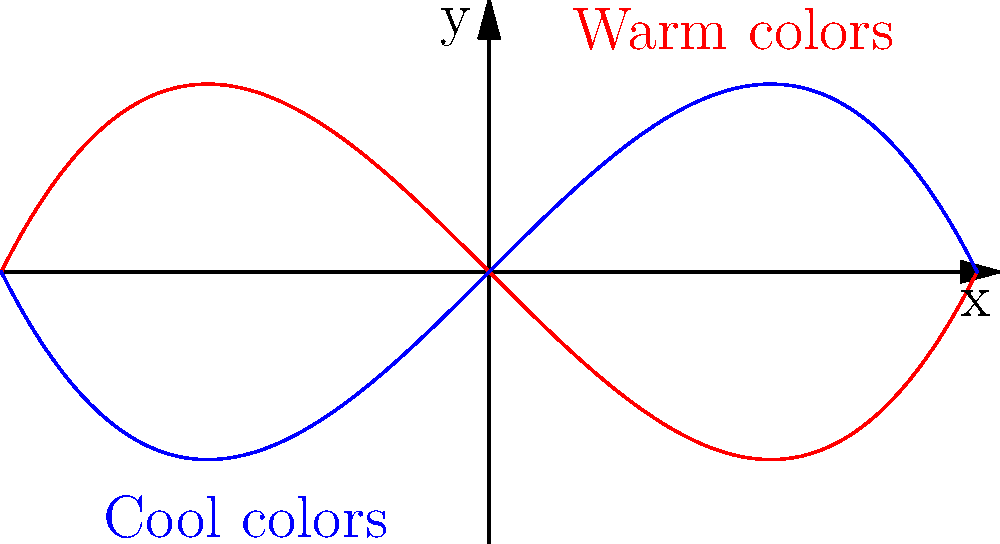In character development, how can the use of warm colors (represented by the red curve) and cool colors (represented by the blue curve) in a character's environment or appearance influence the reader's perception of their emotional state? 1. Color theory in storytelling:
   - Colors evoke emotional responses in readers
   - Warm colors (reds, oranges, yellows) are associated with energy, passion, and intensity
   - Cool colors (blues, greens, purples) are associated with calmness, sadness, or introspection

2. Warm colors (red curve):
   - Rising curve represents increasing emotional intensity
   - Can be used to depict characters feeling anger, excitement, or love
   - Example: A character in a red-lit room might appear more aggressive or passionate

3. Cool colors (blue curve):
   - Descending curve represents decreasing emotional intensity or introspection
   - Can be used to depict characters feeling calm, sad, or contemplative
   - Example: A character surrounded by blue tones might appear more melancholic or thoughtful

4. Intersection points:
   - Where the curves meet represents emotional neutrality or balance
   - Can be used to show character growth or change in emotional state

5. Application in writing:
   - Describe character environments using color-specific language
   - Use color symbolism in clothing or object descriptions
   - Shift color palettes as the character's emotional journey progresses

6. Reader engagement:
   - Subtle use of color theory can subconsciously influence reader perception
   - Consistent color symbolism can reinforce character arcs and themes
Answer: Warm colors evoke intensity and passion, while cool colors suggest calmness or introspection, allowing writers to subtly influence readers' perceptions of characters' emotions through environmental and visual descriptions. 